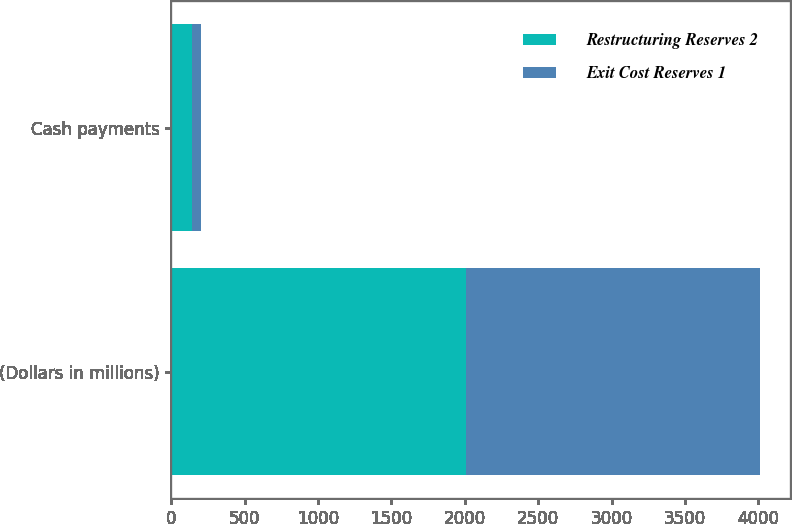<chart> <loc_0><loc_0><loc_500><loc_500><stacked_bar_chart><ecel><fcel>(Dollars in millions)<fcel>Cash payments<nl><fcel>Restructuring Reserves 2<fcel>2007<fcel>139<nl><fcel>Exit Cost Reserves 1<fcel>2007<fcel>61<nl></chart> 